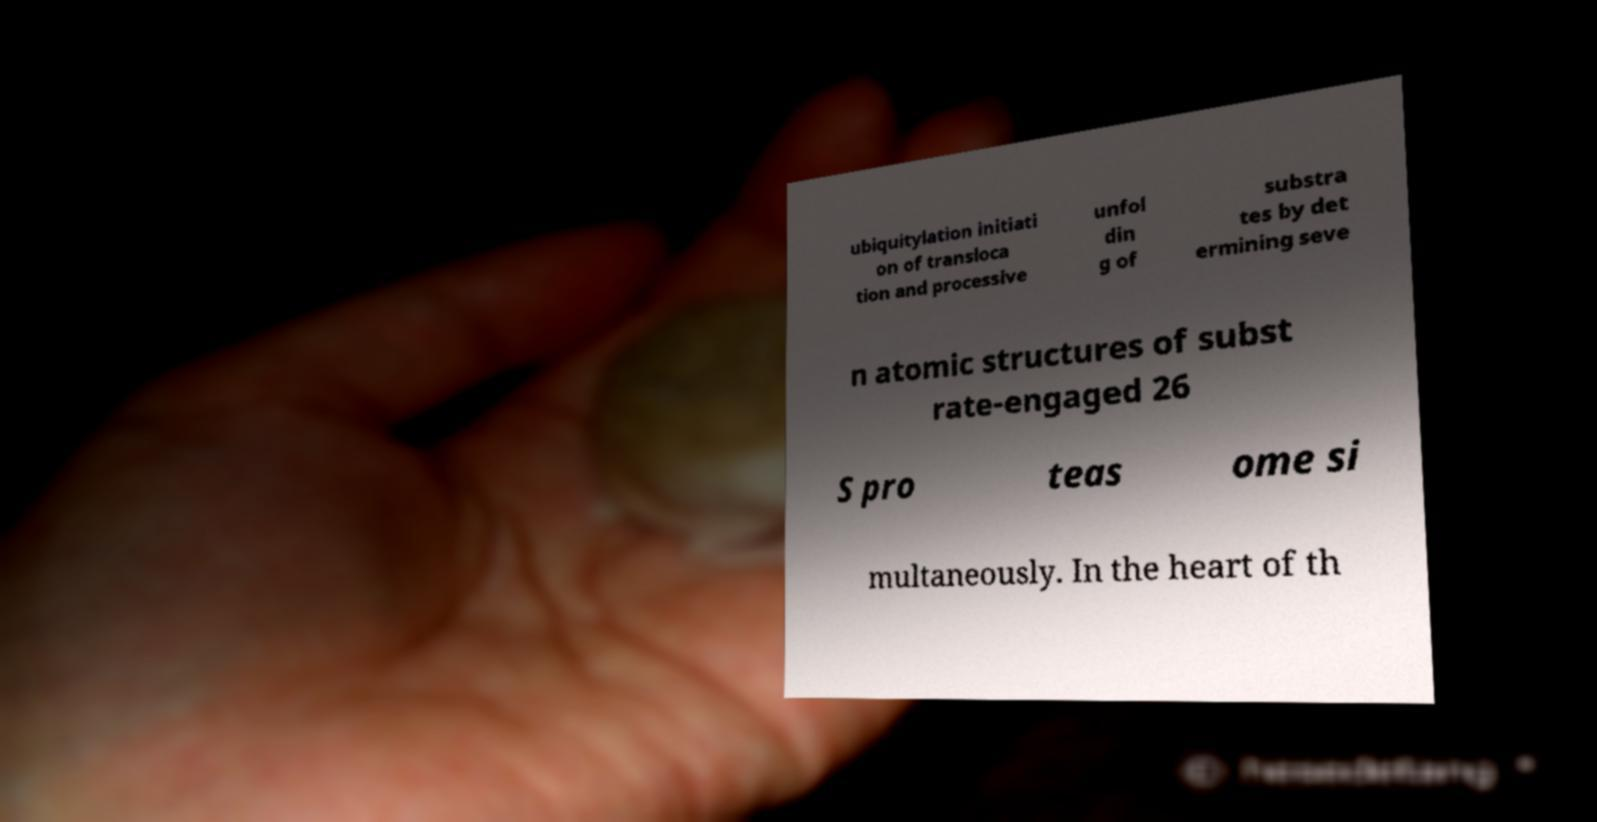I need the written content from this picture converted into text. Can you do that? ubiquitylation initiati on of transloca tion and processive unfol din g of substra tes by det ermining seve n atomic structures of subst rate-engaged 26 S pro teas ome si multaneously. In the heart of th 